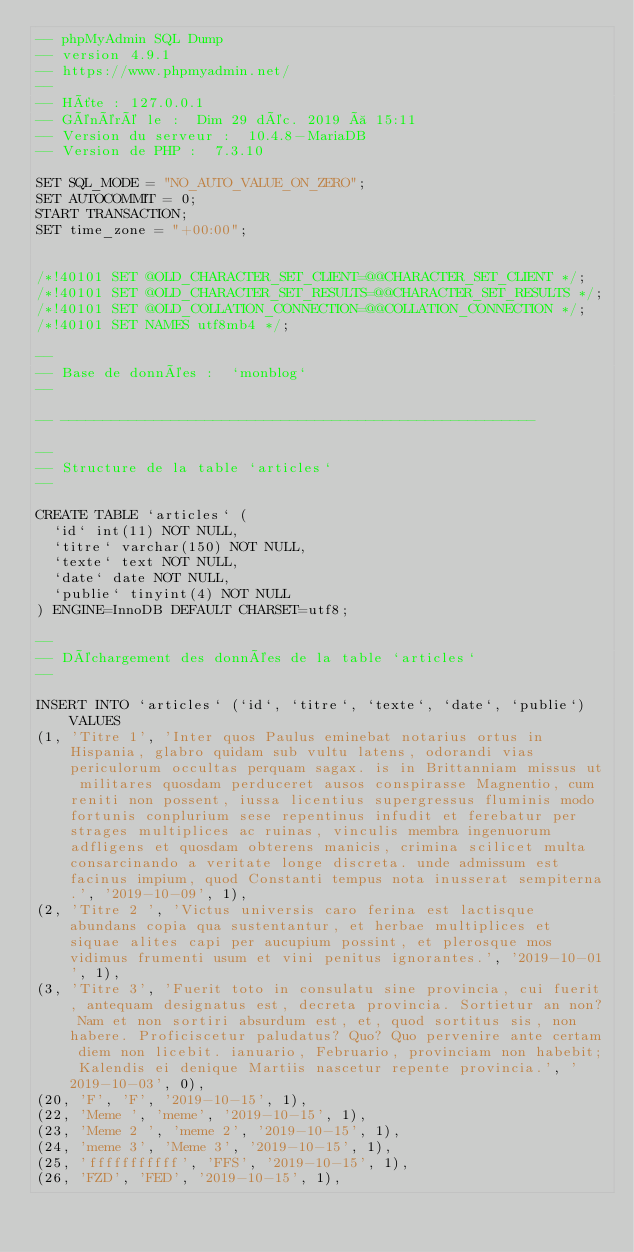Convert code to text. <code><loc_0><loc_0><loc_500><loc_500><_SQL_>-- phpMyAdmin SQL Dump
-- version 4.9.1
-- https://www.phpmyadmin.net/
--
-- Hôte : 127.0.0.1
-- Généré le :  Dim 29 déc. 2019 à 15:11
-- Version du serveur :  10.4.8-MariaDB
-- Version de PHP :  7.3.10

SET SQL_MODE = "NO_AUTO_VALUE_ON_ZERO";
SET AUTOCOMMIT = 0;
START TRANSACTION;
SET time_zone = "+00:00";


/*!40101 SET @OLD_CHARACTER_SET_CLIENT=@@CHARACTER_SET_CLIENT */;
/*!40101 SET @OLD_CHARACTER_SET_RESULTS=@@CHARACTER_SET_RESULTS */;
/*!40101 SET @OLD_COLLATION_CONNECTION=@@COLLATION_CONNECTION */;
/*!40101 SET NAMES utf8mb4 */;

--
-- Base de données :  `monblog`
--

-- --------------------------------------------------------

--
-- Structure de la table `articles`
--

CREATE TABLE `articles` (
  `id` int(11) NOT NULL,
  `titre` varchar(150) NOT NULL,
  `texte` text NOT NULL,
  `date` date NOT NULL,
  `publie` tinyint(4) NOT NULL
) ENGINE=InnoDB DEFAULT CHARSET=utf8;

--
-- Déchargement des données de la table `articles`
--

INSERT INTO `articles` (`id`, `titre`, `texte`, `date`, `publie`) VALUES
(1, 'Titre 1', 'Inter quos Paulus eminebat notarius ortus in Hispania, glabro quidam sub vultu latens, odorandi vias periculorum occultas perquam sagax. is in Brittanniam missus ut militares quosdam perduceret ausos conspirasse Magnentio, cum reniti non possent, iussa licentius supergressus fluminis modo fortunis conplurium sese repentinus infudit et ferebatur per strages multiplices ac ruinas, vinculis membra ingenuorum adfligens et quosdam obterens manicis, crimina scilicet multa consarcinando a veritate longe discreta. unde admissum est facinus impium, quod Constanti tempus nota inusserat sempiterna.', '2019-10-09', 1),
(2, 'Titre 2 ', 'Victus universis caro ferina est lactisque abundans copia qua sustentantur, et herbae multiplices et siquae alites capi per aucupium possint, et plerosque mos vidimus frumenti usum et vini penitus ignorantes.', '2019-10-01', 1),
(3, 'Titre 3', 'Fuerit toto in consulatu sine provincia, cui fuerit, antequam designatus est, decreta provincia. Sortietur an non? Nam et non sortiri absurdum est, et, quod sortitus sis, non habere. Proficiscetur paludatus? Quo? Quo pervenire ante certam diem non licebit. ianuario, Februario, provinciam non habebit; Kalendis ei denique Martiis nascetur repente provincia.', '2019-10-03', 0),
(20, 'F', 'F', '2019-10-15', 1),
(22, 'Meme ', 'meme', '2019-10-15', 1),
(23, 'Meme 2 ', 'meme 2', '2019-10-15', 1),
(24, 'meme 3', 'Meme 3', '2019-10-15', 1),
(25, 'fffffffffff', 'FFS', '2019-10-15', 1),
(26, 'FZD', 'FED', '2019-10-15', 1),</code> 